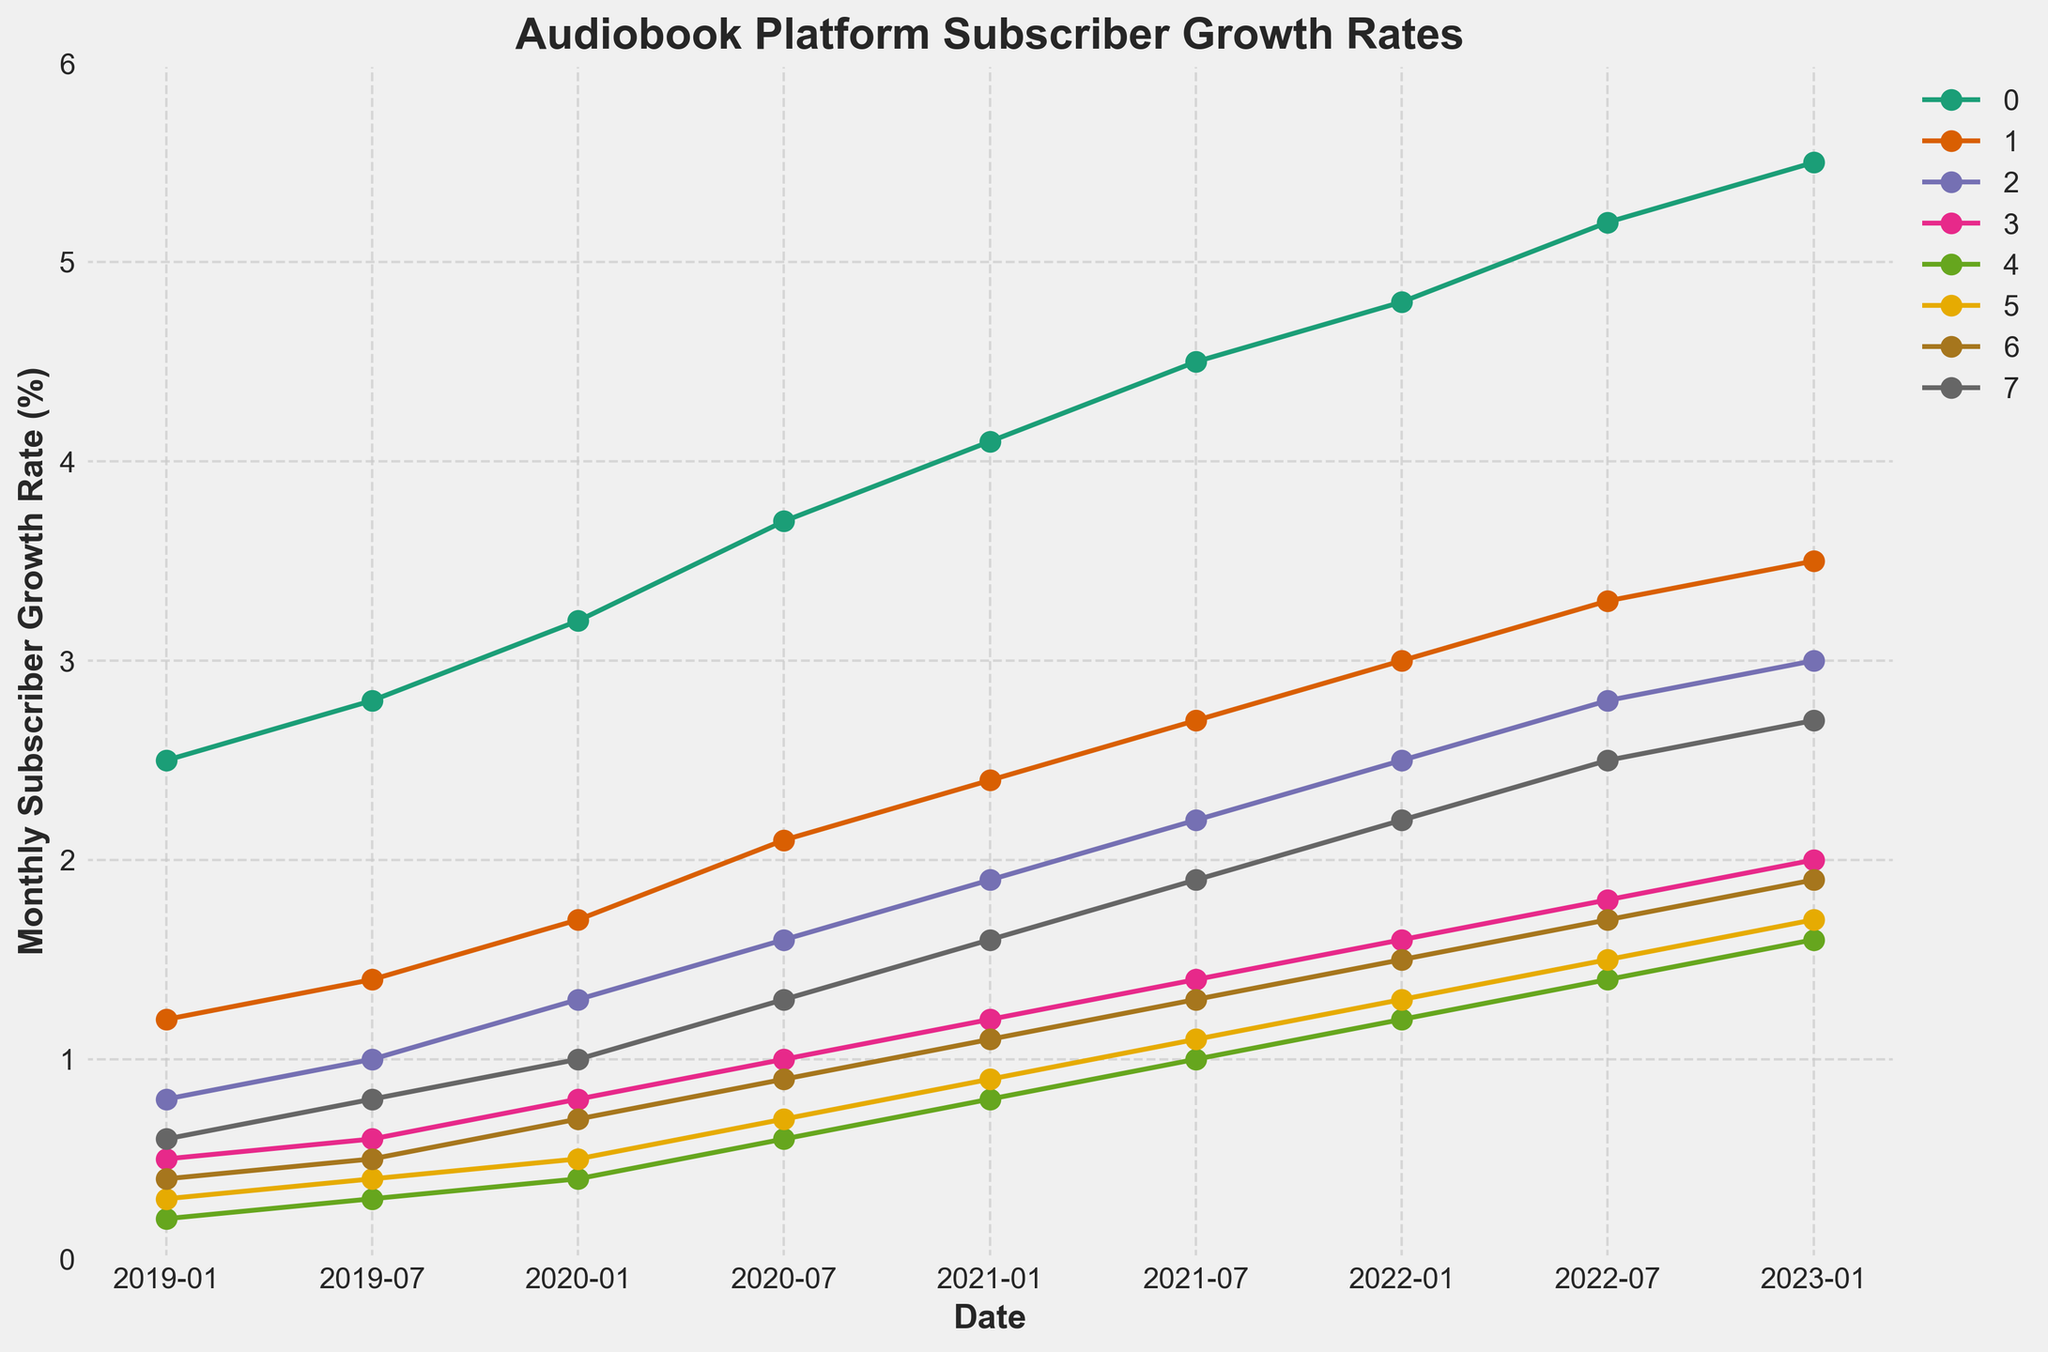Which platform shows the highest growth rate in July 2021? Look at the data points for all platforms in July 2021. Audible has the highest growth rate at 4.5.
Answer: Audible Which two platforms had the same growth rate in January 2020? Check the data points for January 2020. Kobo Audiobooks and Google Play Books both had a growth rate of 0.7.
Answer: Kobo Audiobooks, Google Play Books How much did Audible's growth rate increase from July 2019 to January 2023? Subtract Audible's growth rate in July 2019 from its growth rate in January 2023 (5.5 - 2.8).
Answer: 2.7 What is the average growth rate of Scribd across all given dates? Add all Scribd's growth rates and divide by the number of data points (1.2+1.4+1.7+2.1+2.4+2.7+3.0+3.3+3.5)/9.
Answer: About 2.48 Which platform had the least growth in January 2019, and what was its growth rate? Compare the data points for all platforms in January 2019. Libro.fm had the least growth at 0.2.
Answer: Libro.fm, 0.2 Between which two dates did Storytel see the most significant increase in its growth rate? Compare the growth rate increments between consecutive dates for Storytel. The biggest increase was between January 2020 (1.3) and July 2020 (1.6), an increase of 0.3.
Answer: January 2020 to July 2020 Which platform had higher growth rates than Apple Books in January 2021? Compare the data points for January 2021. Audible (4.1) had a higher growth rate than Apple Books (1.6).
Answer: Audible What is the total growth rate increase for Kobo Audiobooks from January 2019 to July 2022? Subtract Kobo Audiobooks' growth rate in January 2019 from its growth rate in July 2022 (1.5 - 0.3).
Answer: 1.2 How many platforms had a growth rate higher than 1.0 in July 2020? Count the data points greater than 1.0 for July 2020. Audible, Scribd, Storytel, Apple Books, and Google Play Books are 5 platforms.
Answer: 5 Which platform's growth rate was equal to 2.0 in January 2023? Look at the data points for January 2023. Audiobooks.com had a growth rate of exactly 2.0.
Answer: Audiobooks.com 